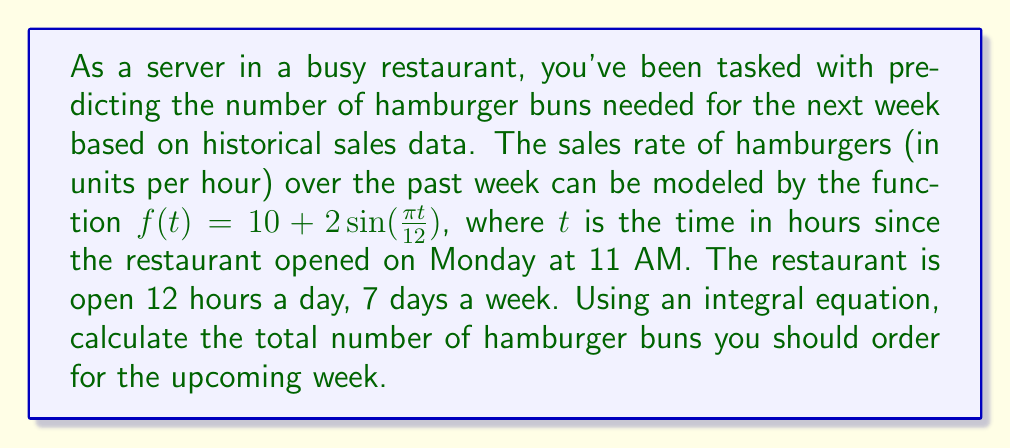Show me your answer to this math problem. To solve this problem, we need to follow these steps:

1) The integral equation for the total number of hamburgers sold over the week is:

   $$N = \int_0^{168} f(t) dt$$

   where 168 is the total number of hours in a week (7 days × 24 hours).

2) We need to integrate the function $f(t) = 10 + 2\sin(\frac{\pi t}{12})$ from 0 to 168:

   $$N = \int_0^{168} (10 + 2\sin(\frac{\pi t}{12})) dt$$

3) Let's break this into two parts:

   $$N = \int_0^{168} 10 dt + \int_0^{168} 2\sin(\frac{\pi t}{12}) dt$$

4) The first part is straightforward:

   $$\int_0^{168} 10 dt = 10t \Big|_0^{168} = 1680$$

5) For the second part, we use the substitution $u = \frac{\pi t}{12}$:

   $$\int_0^{168} 2\sin(\frac{\pi t}{12}) dt = \frac{24}{\pi} \int_0^{14\pi} \sin(u) du = -\frac{24}{\pi} \cos(u) \Big|_0^{14\pi} = 0$$

6) Adding the results from steps 4 and 5:

   $$N = 1680 + 0 = 1680$$

Therefore, you should order 1680 hamburger buns for the upcoming week.
Answer: 1680 buns 